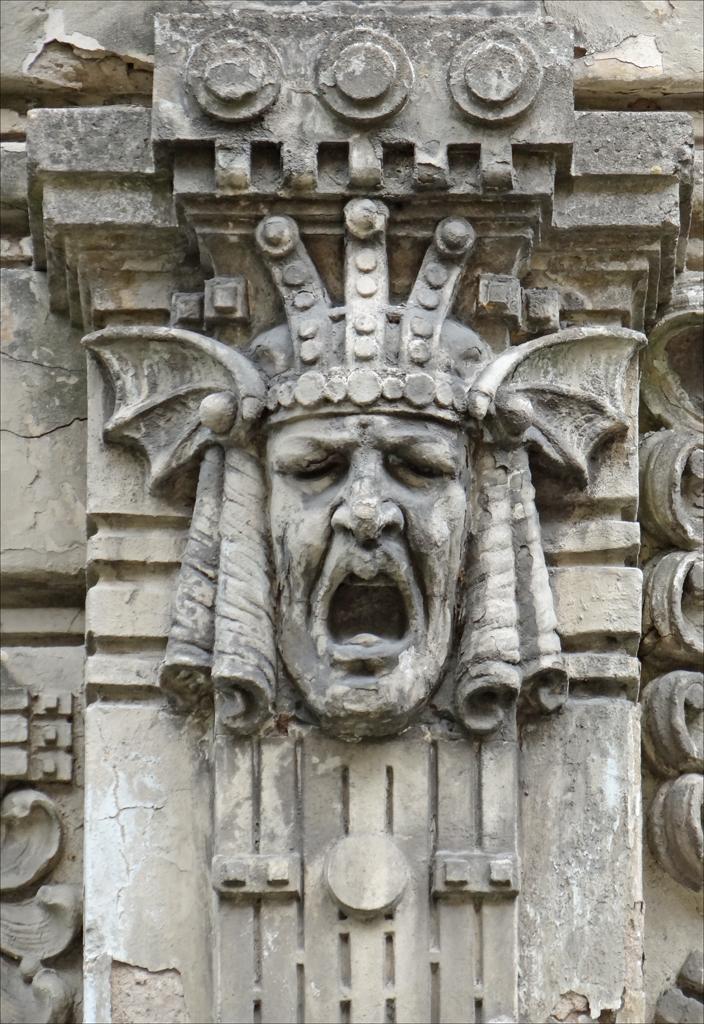In one or two sentences, can you explain what this image depicts? In this image there is a wall on which there is an engraving of a face which is opened. 